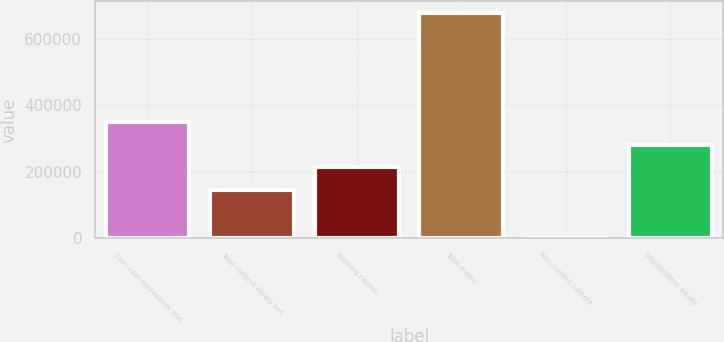Convert chart. <chart><loc_0><loc_0><loc_500><loc_500><bar_chart><fcel>Cash cash equivalents and<fcel>Total content library net<fcel>Working capital<fcel>Total assets<fcel>Non-current content<fcel>Stockholders' equity<nl><fcel>349391<fcel>146139<fcel>213890<fcel>679734<fcel>2227<fcel>281640<nl></chart> 